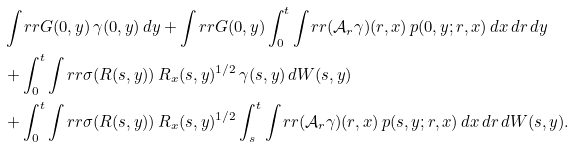<formula> <loc_0><loc_0><loc_500><loc_500>& \int _ { \ } r r G ( 0 , y ) \, \gamma ( 0 , y ) \, d y + \int _ { \ } r r G ( 0 , y ) \int _ { 0 } ^ { t } \int _ { \ } r r ( { \mathcal { A } } _ { r } \gamma ) ( r , x ) \, p ( 0 , y ; r , x ) \, d x \, d r \, d y \\ & + \int _ { 0 } ^ { t } \int _ { \ } r r \sigma ( R ( s , y ) ) \, R _ { x } ( s , y ) ^ { 1 / 2 } \, \gamma ( s , y ) \, d W ( s , y ) \\ & + \int _ { 0 } ^ { t } \int _ { \ } r r \sigma ( R ( s , y ) ) \, R _ { x } ( s , y ) ^ { 1 / 2 } \int _ { s } ^ { t } \int _ { \ } r r ( { \mathcal { A } } _ { r } \gamma ) ( r , x ) \, p ( s , y ; r , x ) \, d x \, d r \, d W ( s , y ) .</formula> 